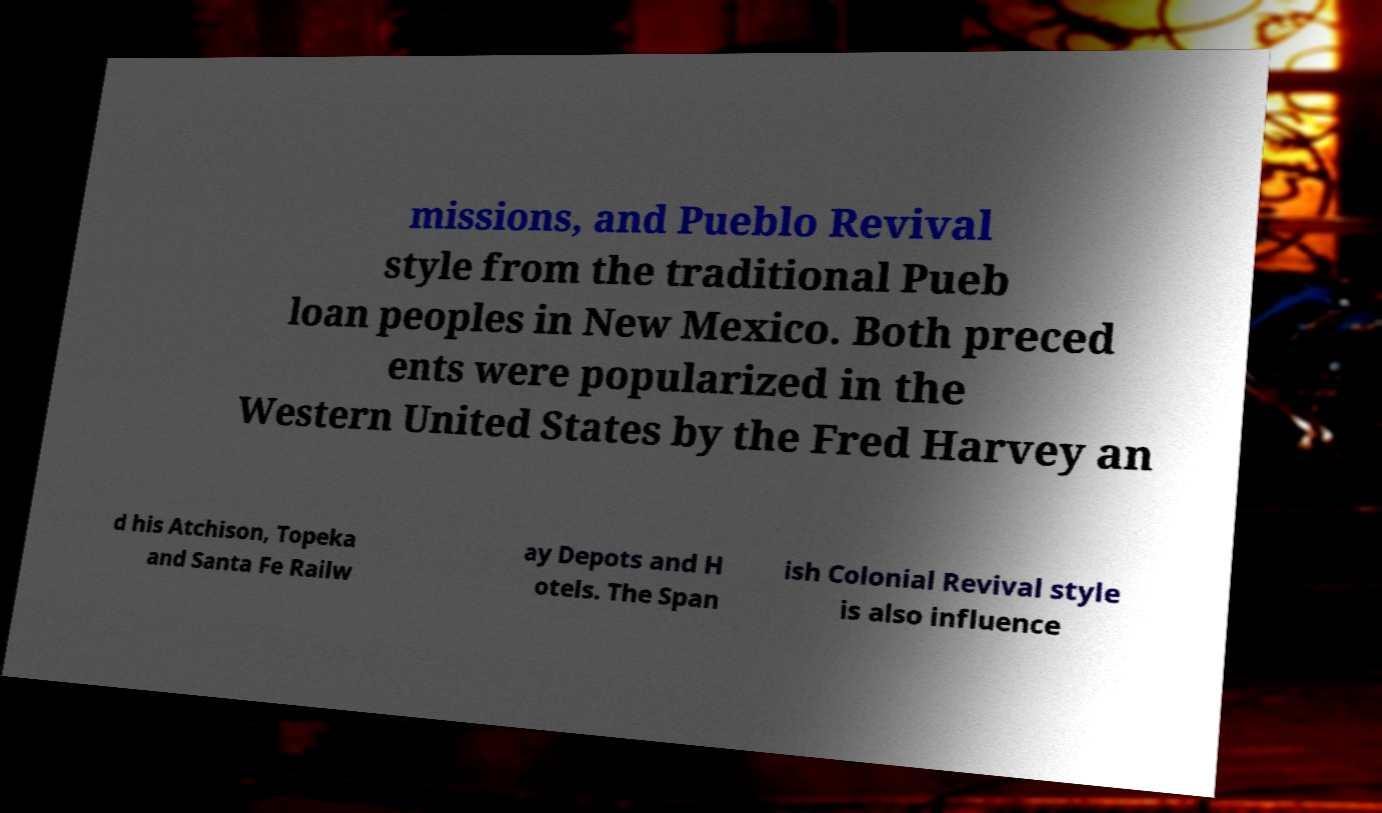Please read and relay the text visible in this image. What does it say? missions, and Pueblo Revival style from the traditional Pueb loan peoples in New Mexico. Both preced ents were popularized in the Western United States by the Fred Harvey an d his Atchison, Topeka and Santa Fe Railw ay Depots and H otels. The Span ish Colonial Revival style is also influence 